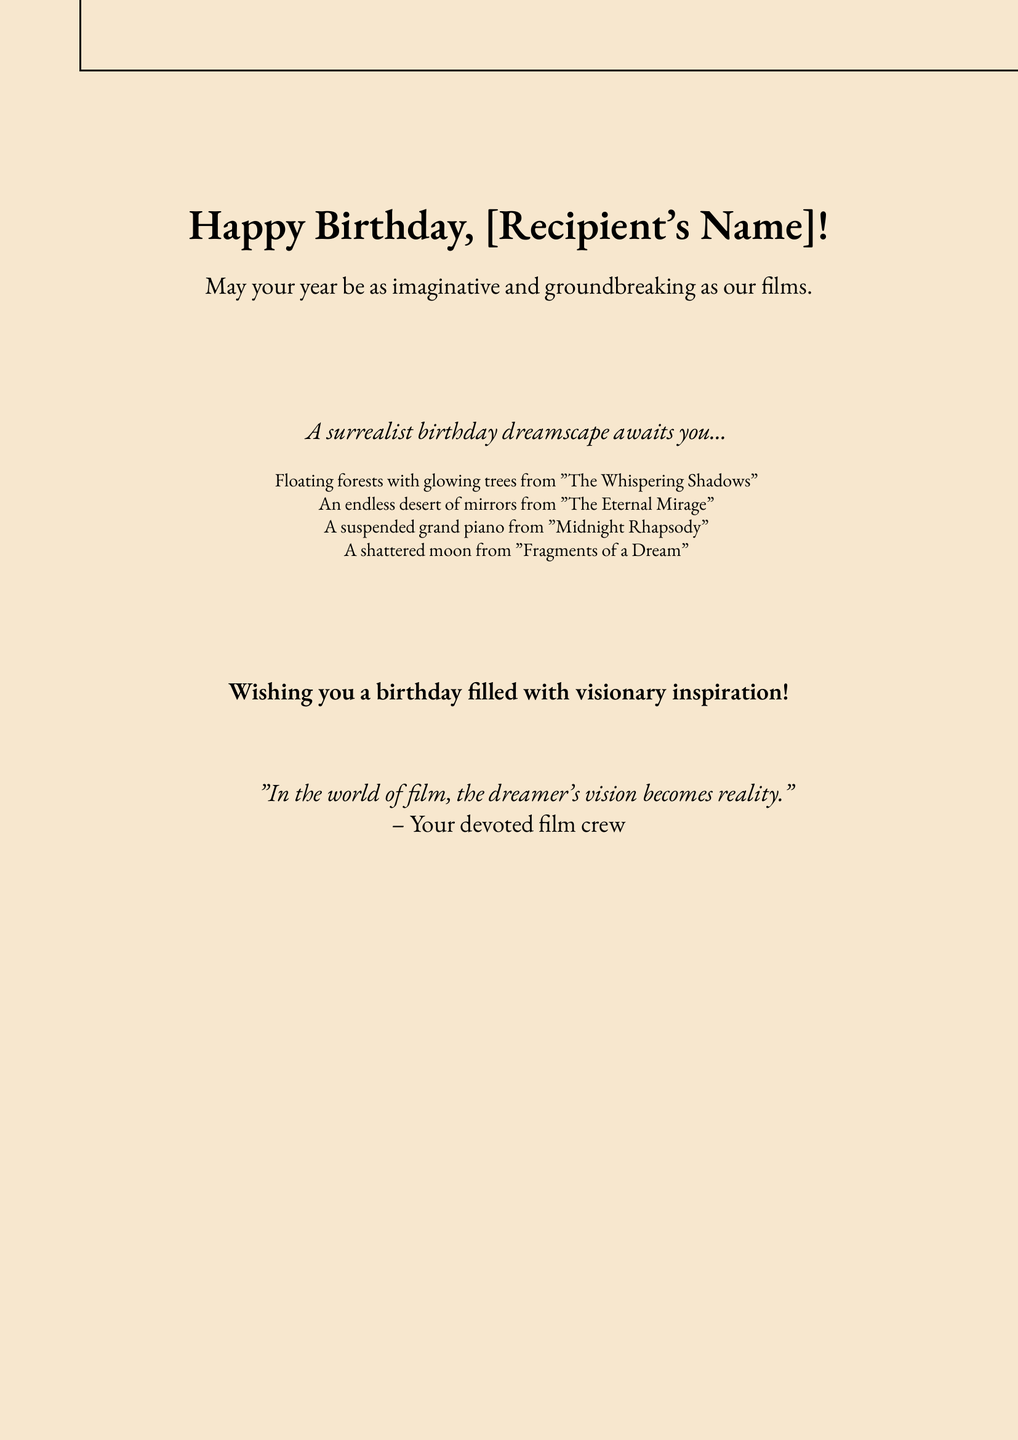What is the title of this greeting card? The title can be found prominently displayed at the top, which is "Happy Birthday, [Recipient's Name]!"
Answer: Happy Birthday, [Recipient's Name]! What is the message for the recipient? The message directly under the title reads, "May your year be as imaginative and groundbreaking as our films."
Answer: May your year be as imaginative and groundbreaking as our films What imagery from "The Whispering Shadows" is mentioned? The document specifies "Floating forests with glowing trees" related to this film.
Answer: Floating forests with glowing trees How many films are referenced in the card? The document lists four films that inspired the surrealist imagery.
Answer: Four What color is the background of the card? The background color is defined in the document and described as "bgColor."
Answer: F7E7CE What type of inspiration does the card wish to give? The closing statement expresses a desire for the recipient to receive visionary inspiration.
Answer: Visionary inspiration Who is credited with the quote in the card? The quotation at the end of the card is credited to "Your devoted film crew."
Answer: Your devoted film crew What does the card describe as being suspended? The text mentions "A suspended grand piano" as part of the imagery.
Answer: A suspended grand piano What is the dominant theme of the birthday card? The overall theme revolves around dreams and imagination, particularly through the lens of film.
Answer: Dreams and imagination 